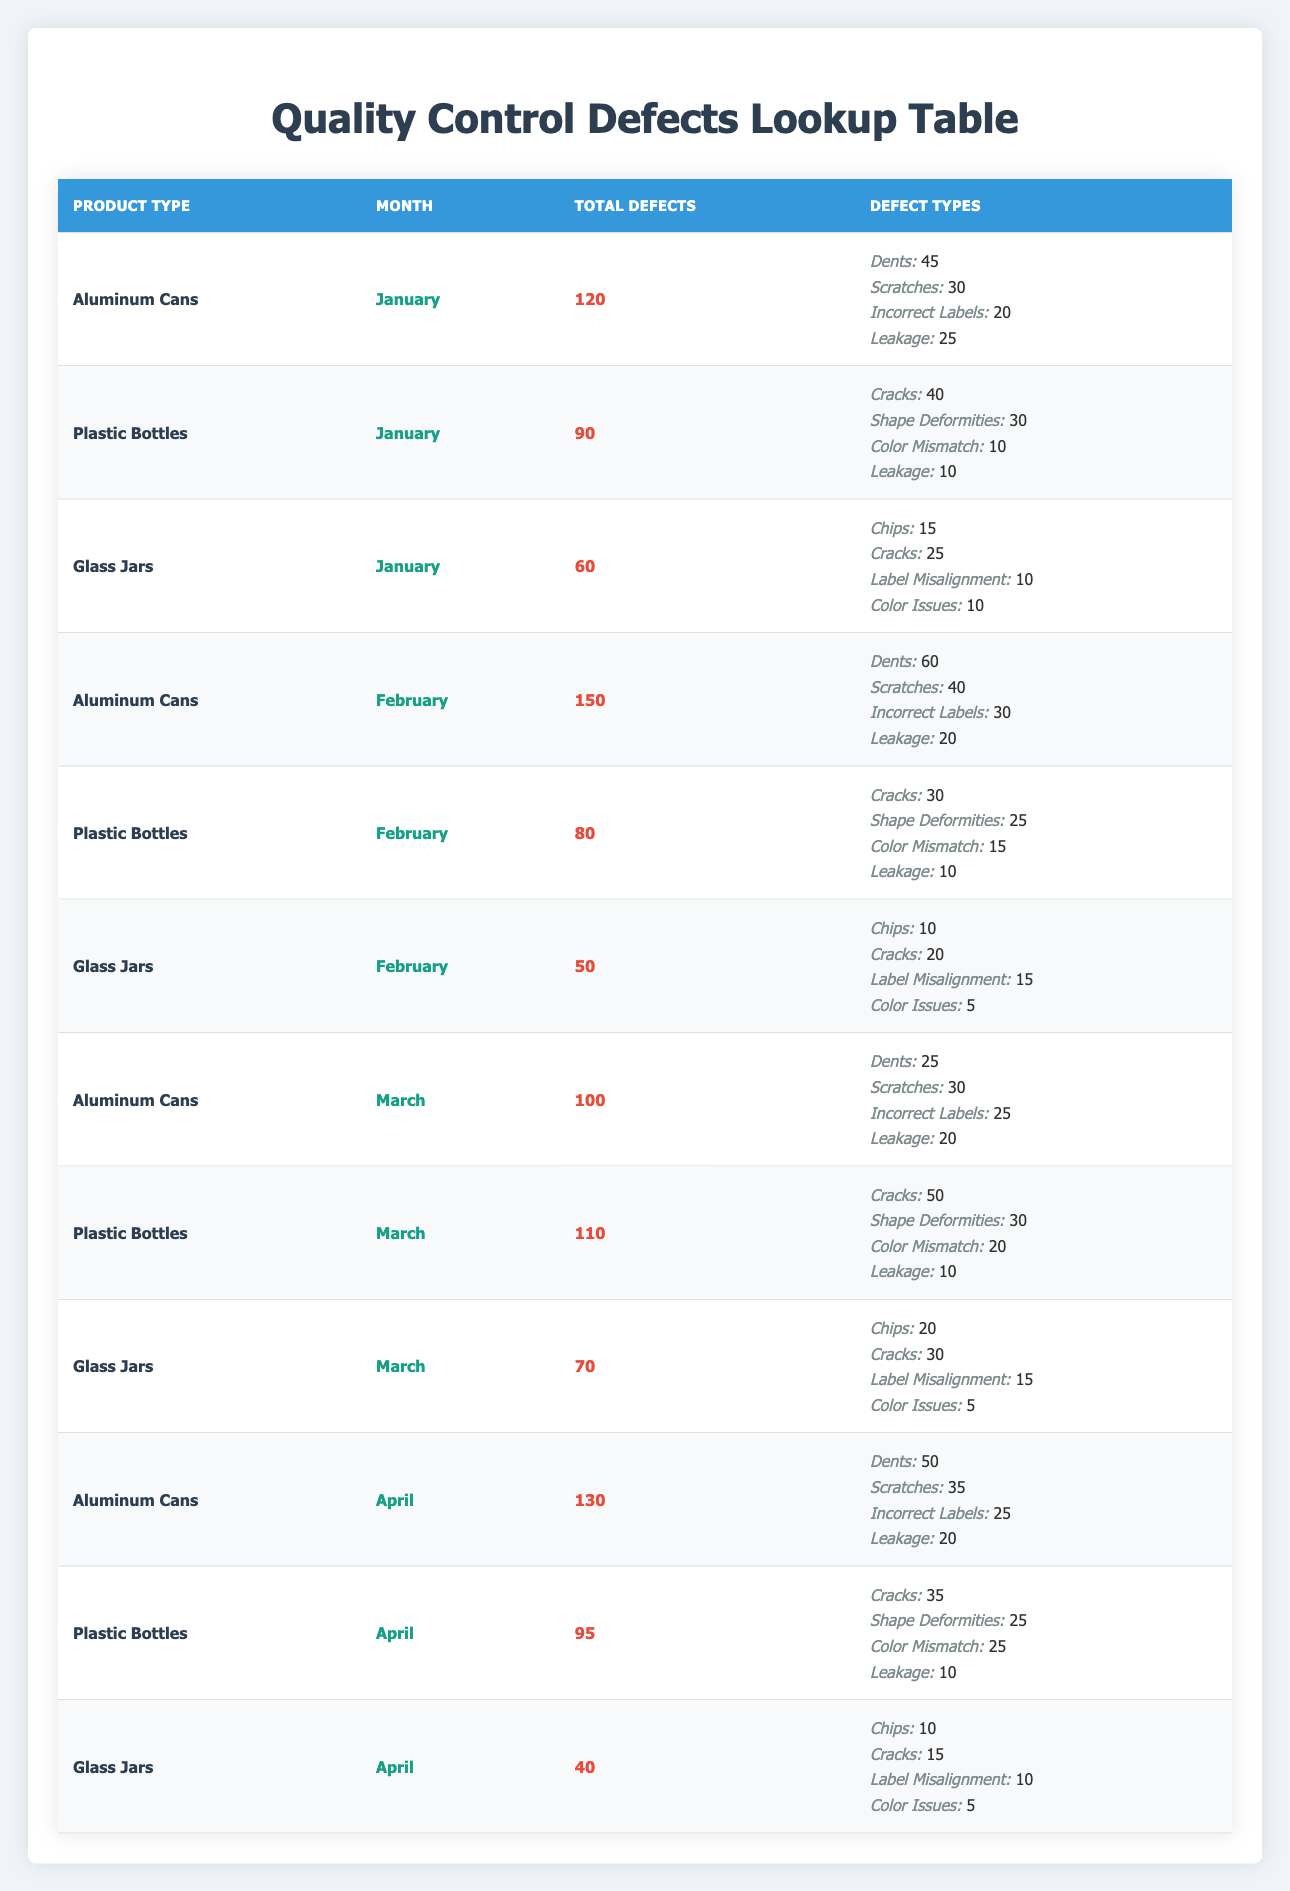What product type had the highest total defects in February? In February, the Aluminum Cans had 150 defects, which is higher than the Plastic Bottles with 80 defects, and the Glass Jars with 50 defects. Therefore, Aluminum Cans had the highest total defects in February.
Answer: Aluminum Cans How many defects did Plastic Bottles have in March? The table shows that during March, Plastic Bottles had a total of 110 defects, as indicated in their row.
Answer: 110 Which month had the highest number of total defects for Glass Jars? Looking at the records for Glass Jars across all months, January had 60 defects, February had 50 defects, March had 70 defects, and April had 40 defects. March has the highest number with 70 defects.
Answer: March What is the combined count of Cracks for Aluminum Cans across all months? The counts for Cracks in Aluminum Cans are: January (0), February (0), March (0), and April (0). Since there were no cracks recorded under Aluminum Cans, the total is 0.
Answer: 0 Did Plastic Bottles experience more defects in March than in January? In January, Plastic Bottles had 90 defects. In March, they had 110 defects, which is greater. Therefore, the statement is true.
Answer: Yes What is the average number of defects for Aluminum Cans across the four months? Aluminum Cans had defects as follows: January (120), February (150), March (100), and April (130). The total is 500, and there are 4 months, so the average is 500/4 = 125.
Answer: 125 Which month had the least amount of defects for Plastic Bottles overall? The counts for Plastic Bottles are: January (90), February (80), March (110), and April (95). Between these, February has the least amount with 80 defects.
Answer: February What was the total sum of Dents for Aluminum Cans over the four months? The Dents for Aluminum Cans were: January (45), February (60), March (25), and April (50). Adding these gives: 45 + 60 + 25 + 50 = 180.
Answer: 180 Was there any month in which Glass Jars had more than 60 defects? Glass Jars had defects as follows: January (60), February (50), March (70), and April (40). March is the only month in which they exceeded 60 defects (70). Therefore, yes, March had more.
Answer: Yes 